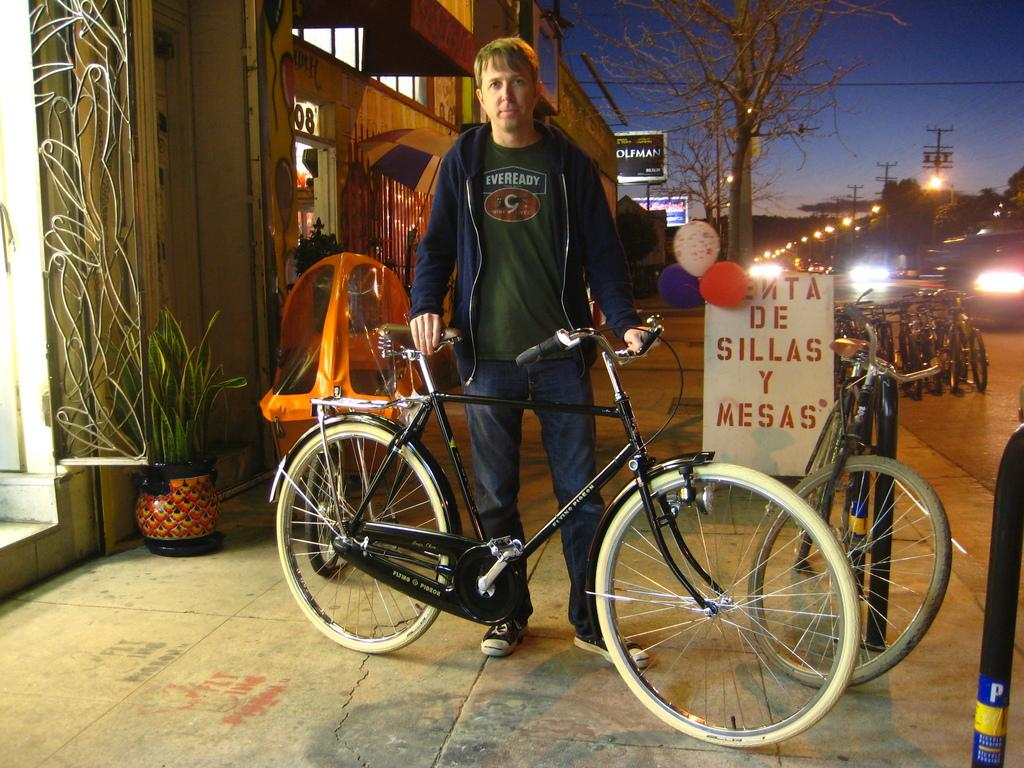What type of transportation can be seen in the image? There are bicycles and vehicles in the image. What else is present in the image besides transportation? There are balloons, plants, boards, electrical poles, light poles, and a person in the image. Can you describe the plants in the image? The plants in the image are not specified, but they are present. What is the person in the image doing? The fact does not specify what the person is doing, so we cannot determine their activity from the given information. What is the opinion of the ant in the image? There is no ant present in the image, so we cannot determine its opinion. What type of cast is present in the image? There is no mention of a cast in the image, so we cannot determine if one is present. 